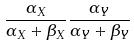Convert formula to latex. <formula><loc_0><loc_0><loc_500><loc_500>\frac { \alpha _ { X } } { \alpha _ { X } + \beta _ { X } } \frac { \alpha _ { Y } } { \alpha _ { Y } + \beta _ { Y } }</formula> 